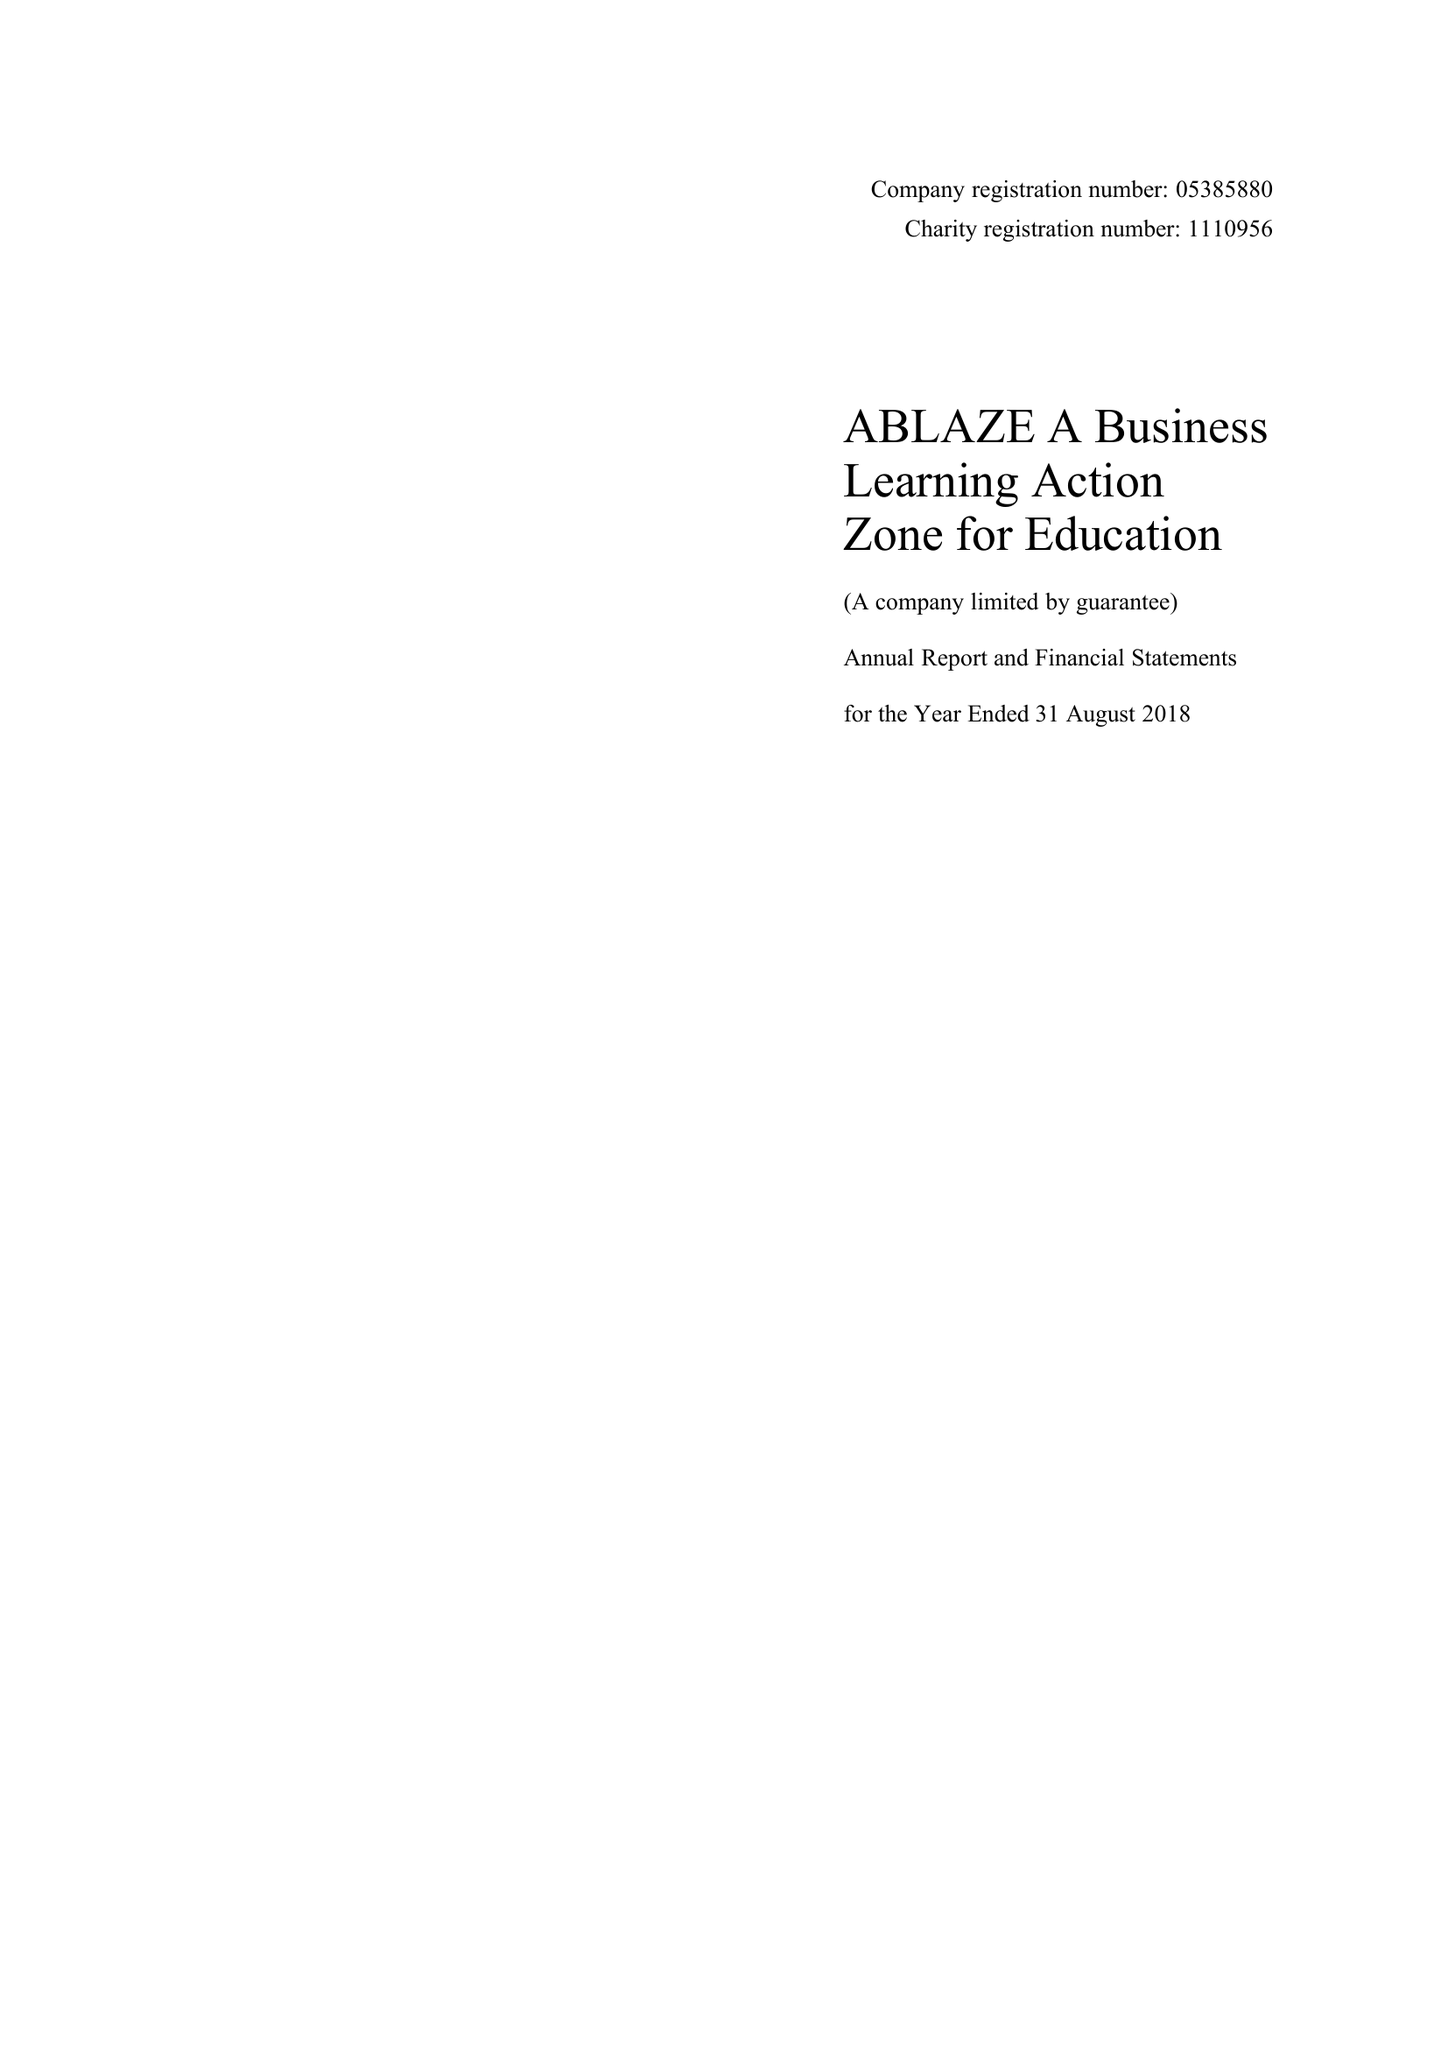What is the value for the income_annually_in_british_pounds?
Answer the question using a single word or phrase. 165344.00 